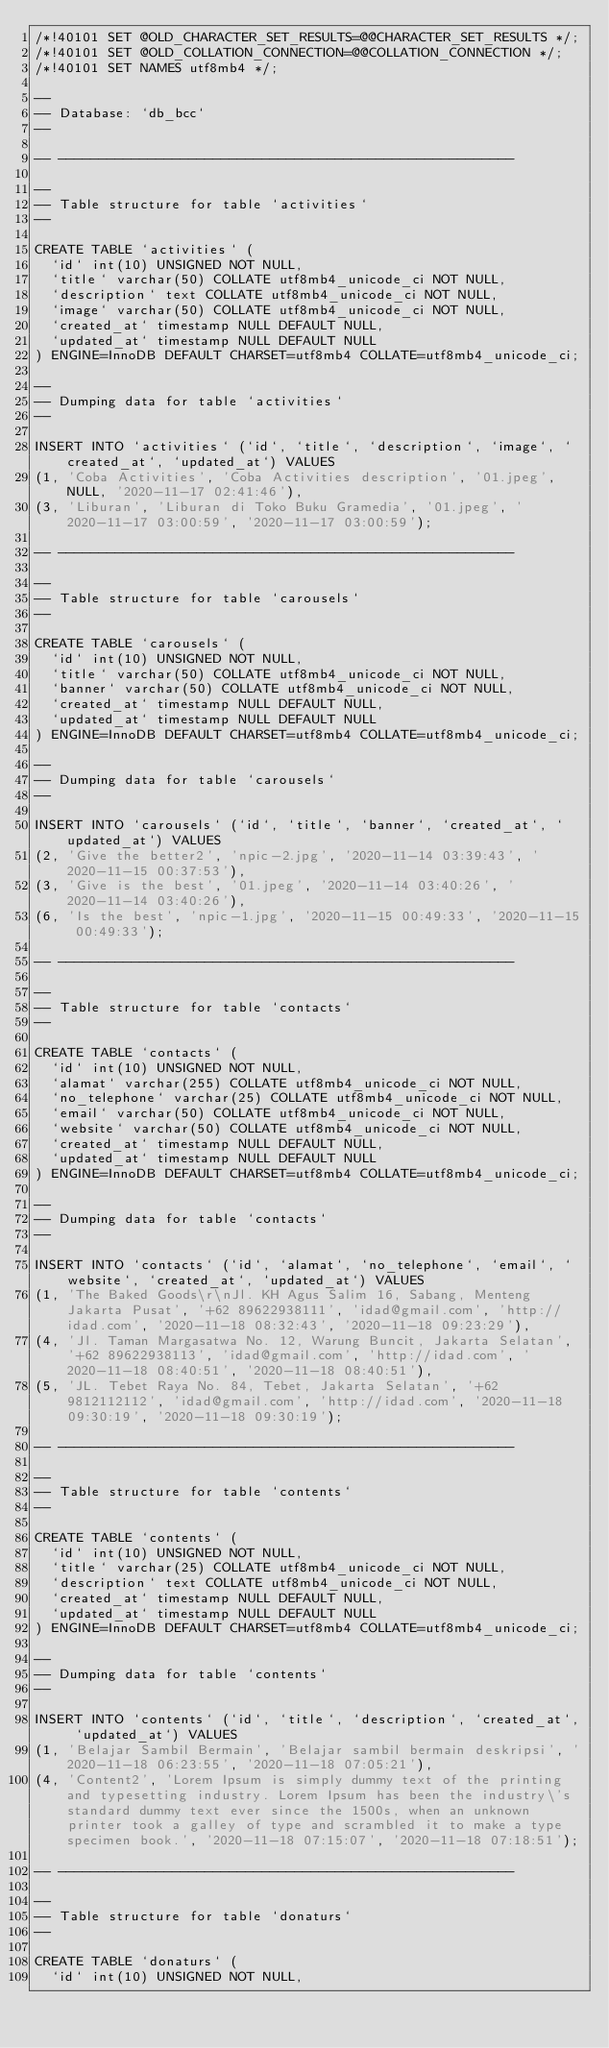<code> <loc_0><loc_0><loc_500><loc_500><_SQL_>/*!40101 SET @OLD_CHARACTER_SET_RESULTS=@@CHARACTER_SET_RESULTS */;
/*!40101 SET @OLD_COLLATION_CONNECTION=@@COLLATION_CONNECTION */;
/*!40101 SET NAMES utf8mb4 */;

--
-- Database: `db_bcc`
--

-- --------------------------------------------------------

--
-- Table structure for table `activities`
--

CREATE TABLE `activities` (
  `id` int(10) UNSIGNED NOT NULL,
  `title` varchar(50) COLLATE utf8mb4_unicode_ci NOT NULL,
  `description` text COLLATE utf8mb4_unicode_ci NOT NULL,
  `image` varchar(50) COLLATE utf8mb4_unicode_ci NOT NULL,
  `created_at` timestamp NULL DEFAULT NULL,
  `updated_at` timestamp NULL DEFAULT NULL
) ENGINE=InnoDB DEFAULT CHARSET=utf8mb4 COLLATE=utf8mb4_unicode_ci;

--
-- Dumping data for table `activities`
--

INSERT INTO `activities` (`id`, `title`, `description`, `image`, `created_at`, `updated_at`) VALUES
(1, 'Coba Activities', 'Coba Activities description', '01.jpeg', NULL, '2020-11-17 02:41:46'),
(3, 'Liburan', 'Liburan di Toko Buku Gramedia', '01.jpeg', '2020-11-17 03:00:59', '2020-11-17 03:00:59');

-- --------------------------------------------------------

--
-- Table structure for table `carousels`
--

CREATE TABLE `carousels` (
  `id` int(10) UNSIGNED NOT NULL,
  `title` varchar(50) COLLATE utf8mb4_unicode_ci NOT NULL,
  `banner` varchar(50) COLLATE utf8mb4_unicode_ci NOT NULL,
  `created_at` timestamp NULL DEFAULT NULL,
  `updated_at` timestamp NULL DEFAULT NULL
) ENGINE=InnoDB DEFAULT CHARSET=utf8mb4 COLLATE=utf8mb4_unicode_ci;

--
-- Dumping data for table `carousels`
--

INSERT INTO `carousels` (`id`, `title`, `banner`, `created_at`, `updated_at`) VALUES
(2, 'Give the better2', 'npic-2.jpg', '2020-11-14 03:39:43', '2020-11-15 00:37:53'),
(3, 'Give is the best', '01.jpeg', '2020-11-14 03:40:26', '2020-11-14 03:40:26'),
(6, 'Is the best', 'npic-1.jpg', '2020-11-15 00:49:33', '2020-11-15 00:49:33');

-- --------------------------------------------------------

--
-- Table structure for table `contacts`
--

CREATE TABLE `contacts` (
  `id` int(10) UNSIGNED NOT NULL,
  `alamat` varchar(255) COLLATE utf8mb4_unicode_ci NOT NULL,
  `no_telephone` varchar(25) COLLATE utf8mb4_unicode_ci NOT NULL,
  `email` varchar(50) COLLATE utf8mb4_unicode_ci NOT NULL,
  `website` varchar(50) COLLATE utf8mb4_unicode_ci NOT NULL,
  `created_at` timestamp NULL DEFAULT NULL,
  `updated_at` timestamp NULL DEFAULT NULL
) ENGINE=InnoDB DEFAULT CHARSET=utf8mb4 COLLATE=utf8mb4_unicode_ci;

--
-- Dumping data for table `contacts`
--

INSERT INTO `contacts` (`id`, `alamat`, `no_telephone`, `email`, `website`, `created_at`, `updated_at`) VALUES
(1, 'The Baked Goods\r\nJl. KH Agus Salim 16, Sabang, Menteng Jakarta Pusat', '+62 89622938111', 'idad@gmail.com', 'http://idad.com', '2020-11-18 08:32:43', '2020-11-18 09:23:29'),
(4, 'Jl. Taman Margasatwa No. 12, Warung Buncit, Jakarta Selatan', '+62 89622938113', 'idad@gmail.com', 'http://idad.com', '2020-11-18 08:40:51', '2020-11-18 08:40:51'),
(5, 'JL. Tebet Raya No. 84, Tebet, Jakarta Selatan', '+62 9812112112', 'idad@gmail.com', 'http://idad.com', '2020-11-18 09:30:19', '2020-11-18 09:30:19');

-- --------------------------------------------------------

--
-- Table structure for table `contents`
--

CREATE TABLE `contents` (
  `id` int(10) UNSIGNED NOT NULL,
  `title` varchar(25) COLLATE utf8mb4_unicode_ci NOT NULL,
  `description` text COLLATE utf8mb4_unicode_ci NOT NULL,
  `created_at` timestamp NULL DEFAULT NULL,
  `updated_at` timestamp NULL DEFAULT NULL
) ENGINE=InnoDB DEFAULT CHARSET=utf8mb4 COLLATE=utf8mb4_unicode_ci;

--
-- Dumping data for table `contents`
--

INSERT INTO `contents` (`id`, `title`, `description`, `created_at`, `updated_at`) VALUES
(1, 'Belajar Sambil Bermain', 'Belajar sambil bermain deskripsi', '2020-11-18 06:23:55', '2020-11-18 07:05:21'),
(4, 'Content2', 'Lorem Ipsum is simply dummy text of the printing and typesetting industry. Lorem Ipsum has been the industry\'s standard dummy text ever since the 1500s, when an unknown printer took a galley of type and scrambled it to make a type specimen book.', '2020-11-18 07:15:07', '2020-11-18 07:18:51');

-- --------------------------------------------------------

--
-- Table structure for table `donaturs`
--

CREATE TABLE `donaturs` (
  `id` int(10) UNSIGNED NOT NULL,</code> 